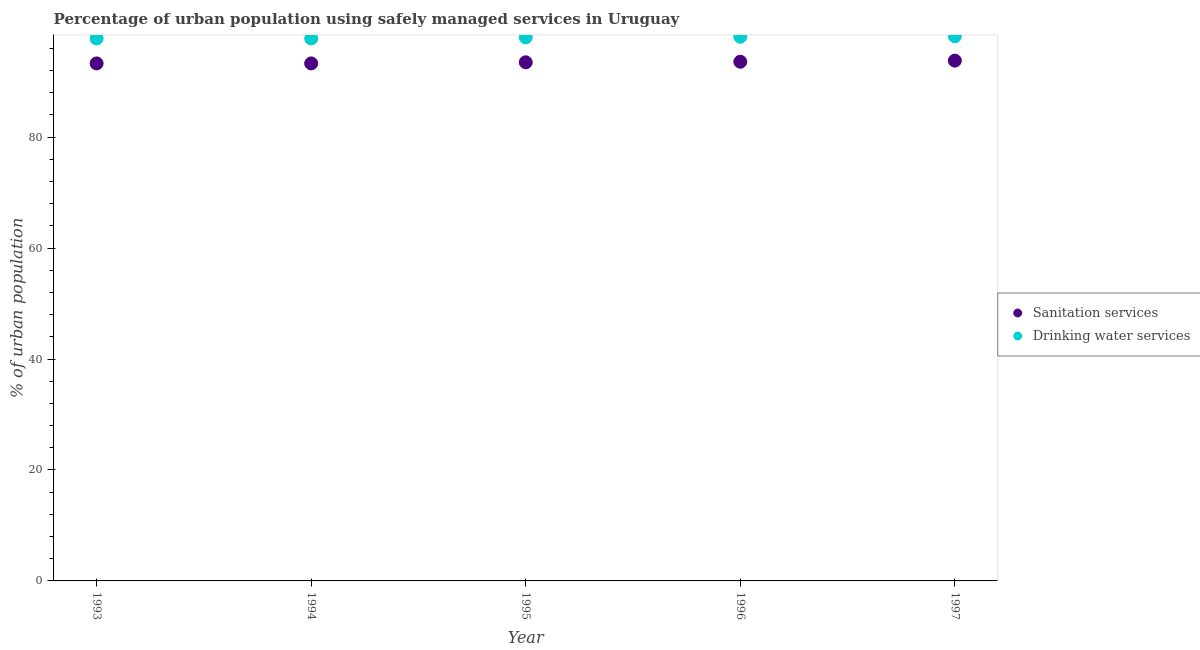How many different coloured dotlines are there?
Make the answer very short. 2. What is the percentage of urban population who used sanitation services in 1995?
Ensure brevity in your answer.  93.5. Across all years, what is the maximum percentage of urban population who used drinking water services?
Provide a succinct answer. 98.2. Across all years, what is the minimum percentage of urban population who used sanitation services?
Make the answer very short. 93.3. In which year was the percentage of urban population who used sanitation services minimum?
Make the answer very short. 1993. What is the total percentage of urban population who used sanitation services in the graph?
Give a very brief answer. 467.5. What is the difference between the percentage of urban population who used sanitation services in 1994 and that in 1996?
Make the answer very short. -0.3. What is the average percentage of urban population who used drinking water services per year?
Your answer should be compact. 97.98. What is the ratio of the percentage of urban population who used drinking water services in 1996 to that in 1997?
Give a very brief answer. 1. Is the percentage of urban population who used sanitation services in 1994 less than that in 1996?
Give a very brief answer. Yes. What is the difference between the highest and the second highest percentage of urban population who used sanitation services?
Keep it short and to the point. 0.2. What is the difference between the highest and the lowest percentage of urban population who used sanitation services?
Your answer should be very brief. 0.5. Is the sum of the percentage of urban population who used drinking water services in 1995 and 1996 greater than the maximum percentage of urban population who used sanitation services across all years?
Your response must be concise. Yes. Does the percentage of urban population who used drinking water services monotonically increase over the years?
Give a very brief answer. No. Is the percentage of urban population who used drinking water services strictly greater than the percentage of urban population who used sanitation services over the years?
Provide a short and direct response. Yes. Is the percentage of urban population who used drinking water services strictly less than the percentage of urban population who used sanitation services over the years?
Your answer should be very brief. No. How many dotlines are there?
Offer a terse response. 2. Are the values on the major ticks of Y-axis written in scientific E-notation?
Your response must be concise. No. Does the graph contain any zero values?
Your response must be concise. No. What is the title of the graph?
Provide a short and direct response. Percentage of urban population using safely managed services in Uruguay. What is the label or title of the X-axis?
Your response must be concise. Year. What is the label or title of the Y-axis?
Offer a very short reply. % of urban population. What is the % of urban population of Sanitation services in 1993?
Make the answer very short. 93.3. What is the % of urban population of Drinking water services in 1993?
Keep it short and to the point. 97.8. What is the % of urban population of Sanitation services in 1994?
Make the answer very short. 93.3. What is the % of urban population in Drinking water services in 1994?
Make the answer very short. 97.8. What is the % of urban population in Sanitation services in 1995?
Provide a short and direct response. 93.5. What is the % of urban population in Sanitation services in 1996?
Make the answer very short. 93.6. What is the % of urban population in Drinking water services in 1996?
Give a very brief answer. 98.1. What is the % of urban population of Sanitation services in 1997?
Your answer should be compact. 93.8. What is the % of urban population of Drinking water services in 1997?
Keep it short and to the point. 98.2. Across all years, what is the maximum % of urban population in Sanitation services?
Offer a terse response. 93.8. Across all years, what is the maximum % of urban population of Drinking water services?
Your answer should be compact. 98.2. Across all years, what is the minimum % of urban population in Sanitation services?
Your answer should be very brief. 93.3. Across all years, what is the minimum % of urban population in Drinking water services?
Give a very brief answer. 97.8. What is the total % of urban population of Sanitation services in the graph?
Keep it short and to the point. 467.5. What is the total % of urban population of Drinking water services in the graph?
Your answer should be compact. 489.9. What is the difference between the % of urban population in Sanitation services in 1993 and that in 1994?
Your answer should be very brief. 0. What is the difference between the % of urban population of Drinking water services in 1993 and that in 1994?
Offer a terse response. 0. What is the difference between the % of urban population in Sanitation services in 1993 and that in 1995?
Your response must be concise. -0.2. What is the difference between the % of urban population in Drinking water services in 1993 and that in 1995?
Provide a succinct answer. -0.2. What is the difference between the % of urban population in Sanitation services in 1993 and that in 1996?
Your answer should be compact. -0.3. What is the difference between the % of urban population of Sanitation services in 1993 and that in 1997?
Ensure brevity in your answer.  -0.5. What is the difference between the % of urban population of Drinking water services in 1993 and that in 1997?
Keep it short and to the point. -0.4. What is the difference between the % of urban population in Sanitation services in 1994 and that in 1995?
Ensure brevity in your answer.  -0.2. What is the difference between the % of urban population of Drinking water services in 1994 and that in 1995?
Your response must be concise. -0.2. What is the difference between the % of urban population of Sanitation services in 1994 and that in 1997?
Provide a succinct answer. -0.5. What is the difference between the % of urban population of Sanitation services in 1995 and that in 1996?
Keep it short and to the point. -0.1. What is the difference between the % of urban population of Drinking water services in 1995 and that in 1996?
Keep it short and to the point. -0.1. What is the difference between the % of urban population in Drinking water services in 1995 and that in 1997?
Offer a terse response. -0.2. What is the difference between the % of urban population in Sanitation services in 1996 and that in 1997?
Give a very brief answer. -0.2. What is the difference between the % of urban population in Drinking water services in 1996 and that in 1997?
Ensure brevity in your answer.  -0.1. What is the difference between the % of urban population in Sanitation services in 1993 and the % of urban population in Drinking water services in 1994?
Offer a very short reply. -4.5. What is the difference between the % of urban population in Sanitation services in 1993 and the % of urban population in Drinking water services in 1996?
Make the answer very short. -4.8. What is the difference between the % of urban population in Sanitation services in 1994 and the % of urban population in Drinking water services in 1995?
Make the answer very short. -4.7. What is the difference between the % of urban population of Sanitation services in 1995 and the % of urban population of Drinking water services in 1996?
Keep it short and to the point. -4.6. What is the average % of urban population in Sanitation services per year?
Provide a short and direct response. 93.5. What is the average % of urban population of Drinking water services per year?
Your answer should be compact. 97.98. In the year 1993, what is the difference between the % of urban population in Sanitation services and % of urban population in Drinking water services?
Your response must be concise. -4.5. In the year 1995, what is the difference between the % of urban population of Sanitation services and % of urban population of Drinking water services?
Offer a very short reply. -4.5. In the year 1997, what is the difference between the % of urban population in Sanitation services and % of urban population in Drinking water services?
Make the answer very short. -4.4. What is the ratio of the % of urban population of Drinking water services in 1993 to that in 1994?
Offer a very short reply. 1. What is the ratio of the % of urban population in Sanitation services in 1993 to that in 1995?
Offer a very short reply. 1. What is the ratio of the % of urban population in Sanitation services in 1993 to that in 1996?
Keep it short and to the point. 1. What is the ratio of the % of urban population of Drinking water services in 1994 to that in 1995?
Your response must be concise. 1. What is the ratio of the % of urban population in Sanitation services in 1994 to that in 1996?
Provide a succinct answer. 1. What is the ratio of the % of urban population in Drinking water services in 1994 to that in 1996?
Offer a very short reply. 1. What is the ratio of the % of urban population of Drinking water services in 1994 to that in 1997?
Offer a terse response. 1. What is the ratio of the % of urban population in Sanitation services in 1995 to that in 1996?
Your response must be concise. 1. What is the ratio of the % of urban population of Drinking water services in 1995 to that in 1996?
Provide a short and direct response. 1. What is the ratio of the % of urban population of Sanitation services in 1995 to that in 1997?
Keep it short and to the point. 1. What is the ratio of the % of urban population in Drinking water services in 1995 to that in 1997?
Ensure brevity in your answer.  1. What is the difference between the highest and the second highest % of urban population of Sanitation services?
Ensure brevity in your answer.  0.2. What is the difference between the highest and the lowest % of urban population in Drinking water services?
Give a very brief answer. 0.4. 